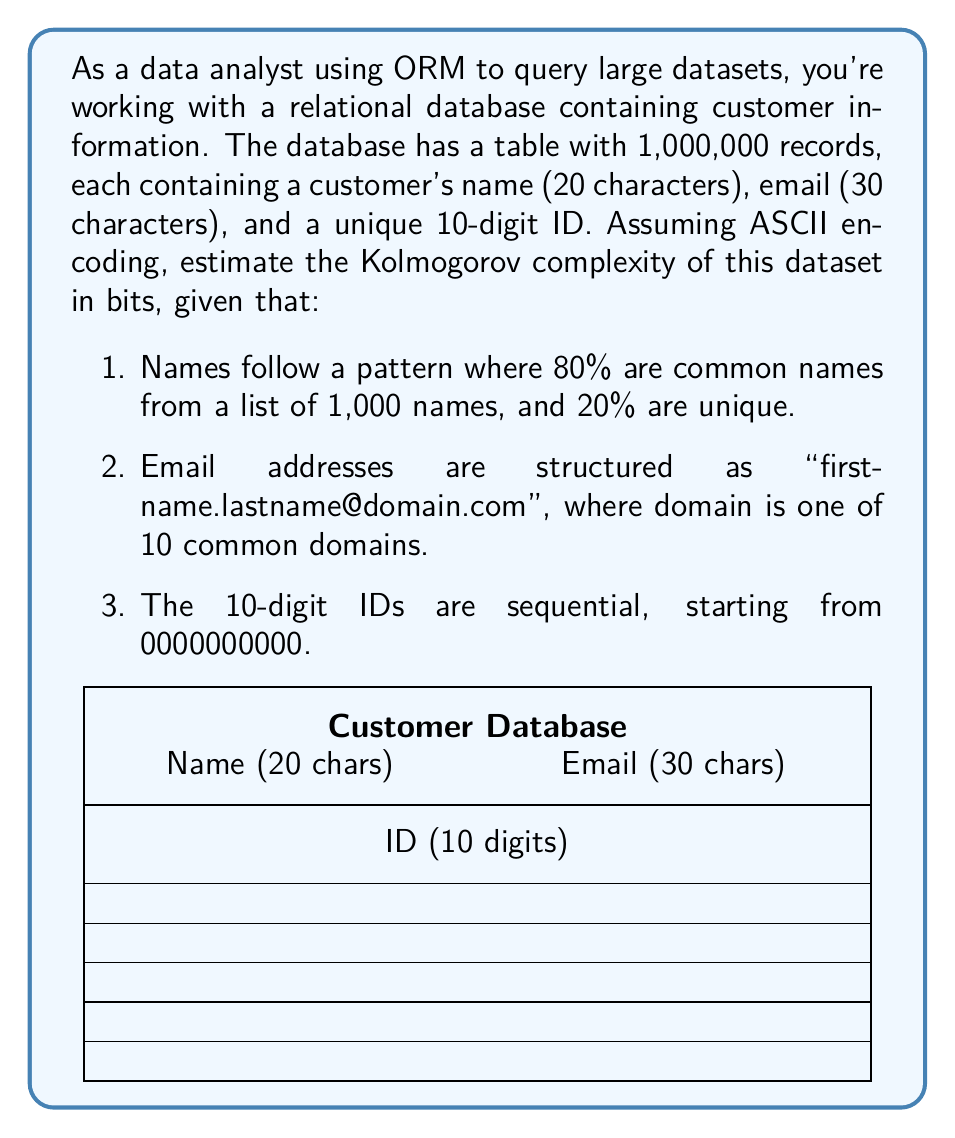Teach me how to tackle this problem. To estimate the Kolmogorov complexity, we need to find a compact way to describe the dataset:

1. Names (20 characters each):
   - 80% common names: $\log_2(1000) \approx 10$ bits per name
   - 20% unique names: 20 characters * 8 bits/char = 160 bits per name
   - Average: $0.8 * 10 + 0.2 * 160 = 40$ bits per name

2. Email addresses (30 characters each):
   - First name: already encoded in the name field
   - Last name: already encoded in the name field
   - Domain: $\log_2(10) \approx 3.32$ bits
   - Structure: can be described in constant bits, negligible for large datasets

3. IDs (10 digits each):
   - Sequential, so we only need to store the starting value (0) and the count (1,000,000)
   - $\log_2(1000000) \approx 20$ bits for the count

Total per record: 40 + 3.32 = 43.32 bits (rounded to 44 bits)

For the entire dataset:
- Names and emails: 1,000,000 * 44 = 44,000,000 bits
- IDs: 20 bits (for the count)
- Description of the data structure and patterns: ~1000 bits (constant overhead)

Estimated Kolmogorov complexity: 44,000,000 + 20 + 1000 = 44,001,020 bits
Answer: 44,001,020 bits 